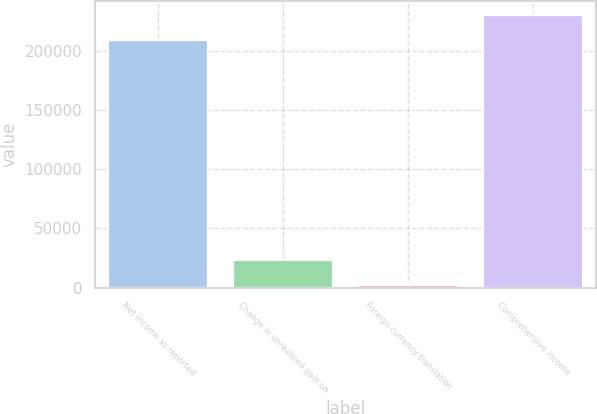Convert chart. <chart><loc_0><loc_0><loc_500><loc_500><bar_chart><fcel>Net income as reported<fcel>Change in unrealized gain on<fcel>Foreign currency translation<fcel>Comprehensive income<nl><fcel>208716<fcel>23365.7<fcel>2087<fcel>229995<nl></chart> 